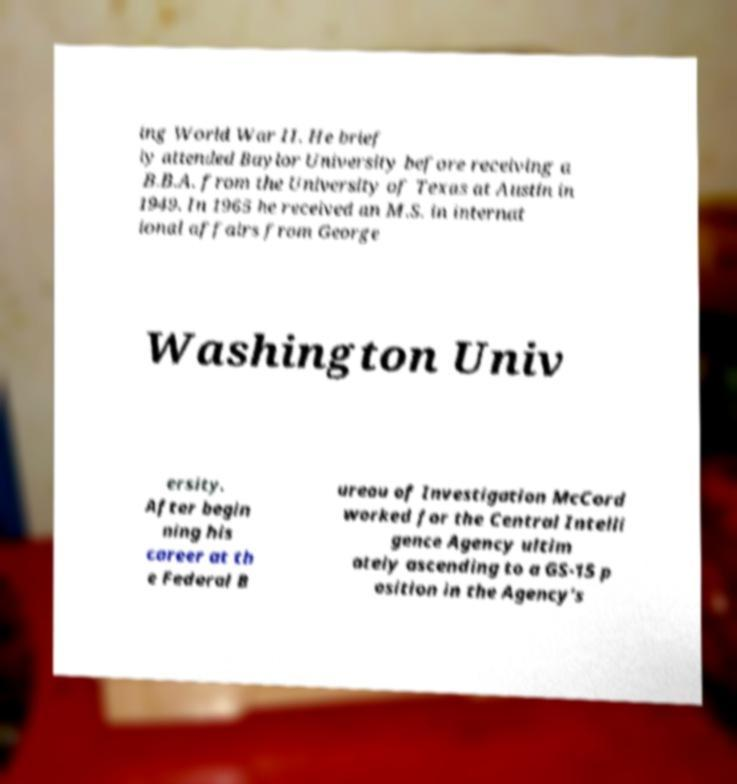Can you accurately transcribe the text from the provided image for me? ing World War II. He brief ly attended Baylor University before receiving a B.B.A. from the University of Texas at Austin in 1949. In 1965 he received an M.S. in internat ional affairs from George Washington Univ ersity. After begin ning his career at th e Federal B ureau of Investigation McCord worked for the Central Intelli gence Agency ultim ately ascending to a GS-15 p osition in the Agency's 